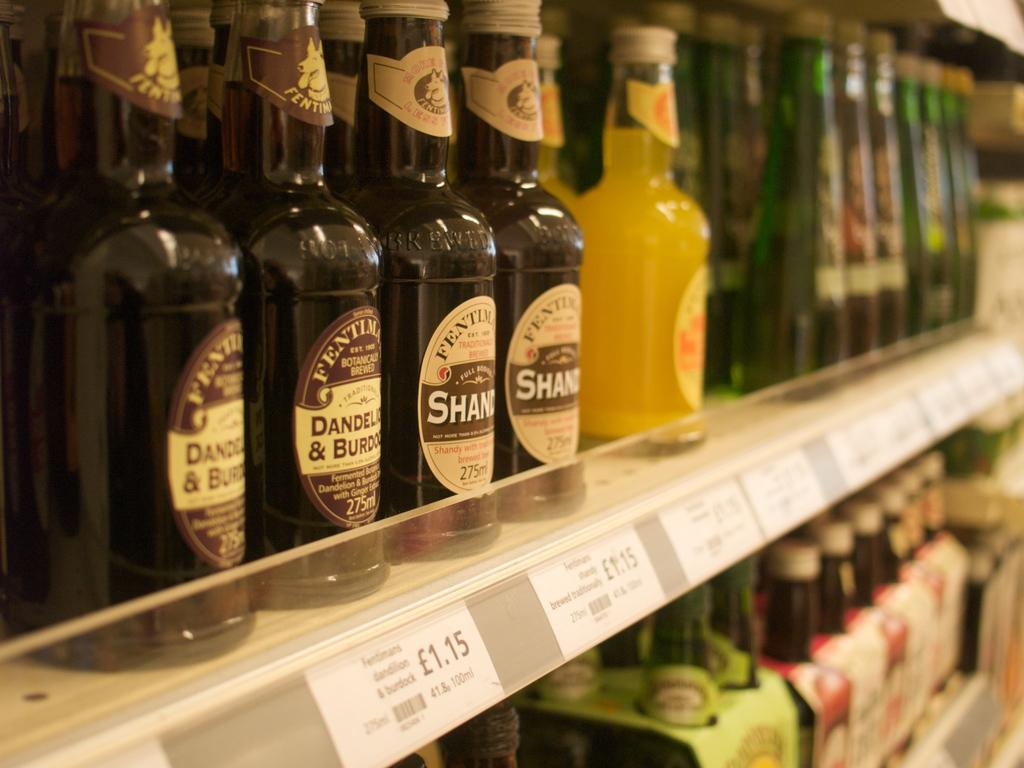<image>
Create a compact narrative representing the image presented. Bottles of Shandy beer are on a shelf. 